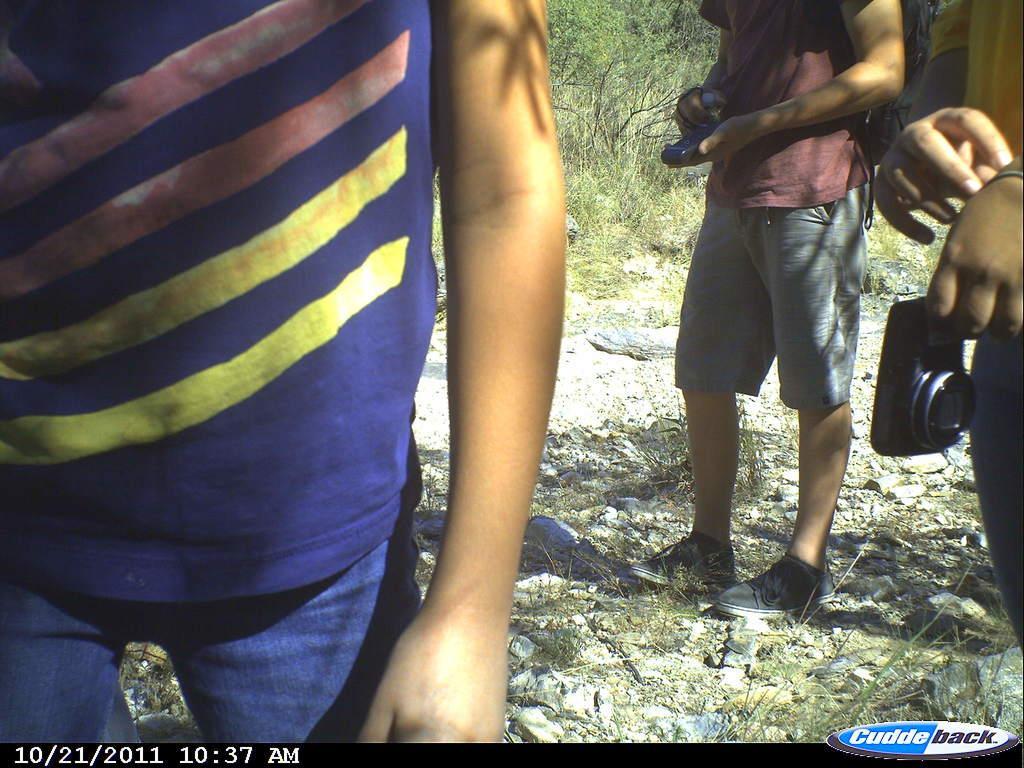How would you summarize this image in a sentence or two? In this picture, we see three men standing. The man on the right side is holding the camera in his hand. Beside him, the man in brown T-shirt is holding a blue color thing in his hands. Behind him, there are trees. At the bottom of the picture, we see the grass and the stones. 